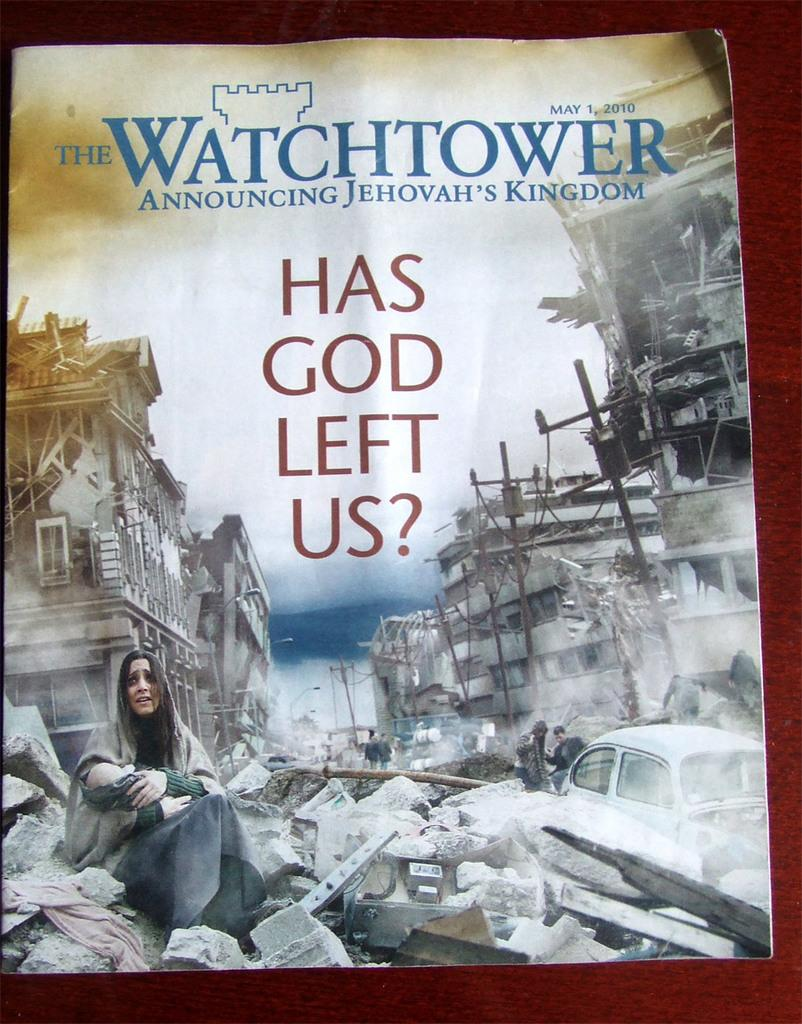<image>
Create a compact narrative representing the image presented. A Watchtower magazine titled "Has God Left Us?" 